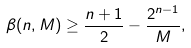Convert formula to latex. <formula><loc_0><loc_0><loc_500><loc_500>\beta ( n , M ) \geq \frac { n + 1 } { 2 } - \frac { 2 ^ { n - 1 } } { M } ,</formula> 